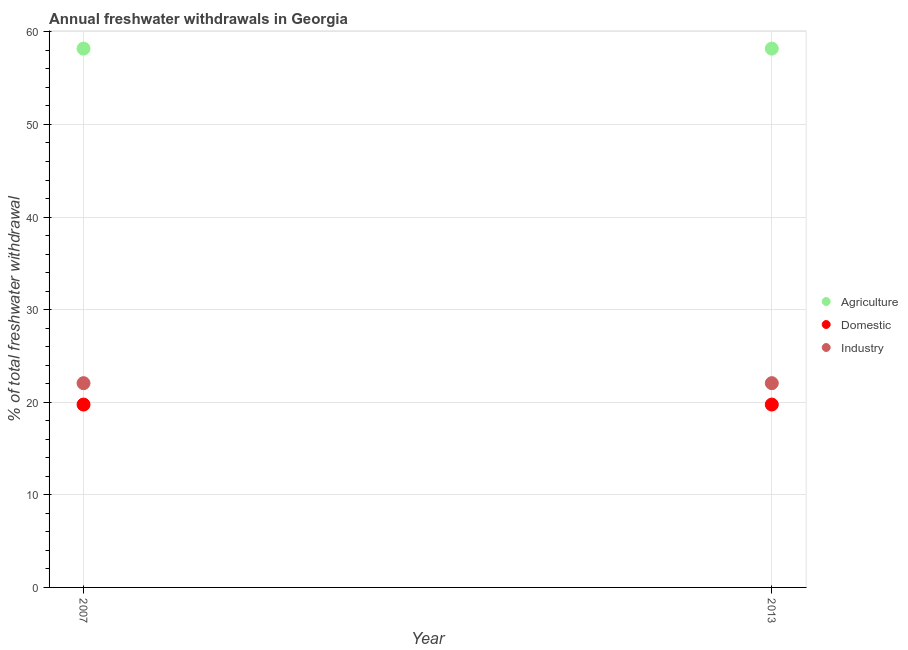How many different coloured dotlines are there?
Your answer should be compact. 3. What is the percentage of freshwater withdrawal for agriculture in 2013?
Offer a terse response. 58.19. Across all years, what is the maximum percentage of freshwater withdrawal for domestic purposes?
Your answer should be compact. 19.75. Across all years, what is the minimum percentage of freshwater withdrawal for agriculture?
Give a very brief answer. 58.19. What is the total percentage of freshwater withdrawal for domestic purposes in the graph?
Offer a terse response. 39.5. What is the difference between the percentage of freshwater withdrawal for industry in 2007 and the percentage of freshwater withdrawal for agriculture in 2013?
Offer a terse response. -36.13. What is the average percentage of freshwater withdrawal for agriculture per year?
Your response must be concise. 58.19. In the year 2007, what is the difference between the percentage of freshwater withdrawal for domestic purposes and percentage of freshwater withdrawal for agriculture?
Keep it short and to the point. -38.44. In how many years, is the percentage of freshwater withdrawal for agriculture greater than 18 %?
Keep it short and to the point. 2. What is the ratio of the percentage of freshwater withdrawal for domestic purposes in 2007 to that in 2013?
Your answer should be compact. 1. Is the percentage of freshwater withdrawal for agriculture in 2007 less than that in 2013?
Your answer should be very brief. No. In how many years, is the percentage of freshwater withdrawal for domestic purposes greater than the average percentage of freshwater withdrawal for domestic purposes taken over all years?
Keep it short and to the point. 0. Is the percentage of freshwater withdrawal for domestic purposes strictly greater than the percentage of freshwater withdrawal for agriculture over the years?
Provide a short and direct response. No. How many years are there in the graph?
Keep it short and to the point. 2. Does the graph contain any zero values?
Provide a succinct answer. No. How many legend labels are there?
Your answer should be very brief. 3. How are the legend labels stacked?
Offer a very short reply. Vertical. What is the title of the graph?
Provide a succinct answer. Annual freshwater withdrawals in Georgia. What is the label or title of the X-axis?
Your response must be concise. Year. What is the label or title of the Y-axis?
Your response must be concise. % of total freshwater withdrawal. What is the % of total freshwater withdrawal in Agriculture in 2007?
Your response must be concise. 58.19. What is the % of total freshwater withdrawal of Domestic in 2007?
Offer a terse response. 19.75. What is the % of total freshwater withdrawal in Industry in 2007?
Offer a terse response. 22.06. What is the % of total freshwater withdrawal in Agriculture in 2013?
Provide a short and direct response. 58.19. What is the % of total freshwater withdrawal in Domestic in 2013?
Keep it short and to the point. 19.75. What is the % of total freshwater withdrawal of Industry in 2013?
Your answer should be compact. 22.06. Across all years, what is the maximum % of total freshwater withdrawal of Agriculture?
Your answer should be compact. 58.19. Across all years, what is the maximum % of total freshwater withdrawal in Domestic?
Give a very brief answer. 19.75. Across all years, what is the maximum % of total freshwater withdrawal of Industry?
Make the answer very short. 22.06. Across all years, what is the minimum % of total freshwater withdrawal in Agriculture?
Your answer should be compact. 58.19. Across all years, what is the minimum % of total freshwater withdrawal of Domestic?
Your answer should be very brief. 19.75. Across all years, what is the minimum % of total freshwater withdrawal in Industry?
Make the answer very short. 22.06. What is the total % of total freshwater withdrawal of Agriculture in the graph?
Make the answer very short. 116.38. What is the total % of total freshwater withdrawal of Domestic in the graph?
Your answer should be very brief. 39.5. What is the total % of total freshwater withdrawal in Industry in the graph?
Your response must be concise. 44.12. What is the difference between the % of total freshwater withdrawal in Agriculture in 2007 and that in 2013?
Make the answer very short. 0. What is the difference between the % of total freshwater withdrawal of Industry in 2007 and that in 2013?
Offer a very short reply. 0. What is the difference between the % of total freshwater withdrawal of Agriculture in 2007 and the % of total freshwater withdrawal of Domestic in 2013?
Offer a terse response. 38.44. What is the difference between the % of total freshwater withdrawal of Agriculture in 2007 and the % of total freshwater withdrawal of Industry in 2013?
Keep it short and to the point. 36.13. What is the difference between the % of total freshwater withdrawal of Domestic in 2007 and the % of total freshwater withdrawal of Industry in 2013?
Offer a terse response. -2.31. What is the average % of total freshwater withdrawal in Agriculture per year?
Offer a very short reply. 58.19. What is the average % of total freshwater withdrawal in Domestic per year?
Ensure brevity in your answer.  19.75. What is the average % of total freshwater withdrawal in Industry per year?
Provide a succinct answer. 22.06. In the year 2007, what is the difference between the % of total freshwater withdrawal in Agriculture and % of total freshwater withdrawal in Domestic?
Ensure brevity in your answer.  38.44. In the year 2007, what is the difference between the % of total freshwater withdrawal in Agriculture and % of total freshwater withdrawal in Industry?
Provide a short and direct response. 36.13. In the year 2007, what is the difference between the % of total freshwater withdrawal in Domestic and % of total freshwater withdrawal in Industry?
Provide a succinct answer. -2.31. In the year 2013, what is the difference between the % of total freshwater withdrawal in Agriculture and % of total freshwater withdrawal in Domestic?
Keep it short and to the point. 38.44. In the year 2013, what is the difference between the % of total freshwater withdrawal in Agriculture and % of total freshwater withdrawal in Industry?
Make the answer very short. 36.13. In the year 2013, what is the difference between the % of total freshwater withdrawal of Domestic and % of total freshwater withdrawal of Industry?
Your response must be concise. -2.31. What is the ratio of the % of total freshwater withdrawal in Agriculture in 2007 to that in 2013?
Offer a very short reply. 1. What is the difference between the highest and the second highest % of total freshwater withdrawal in Agriculture?
Make the answer very short. 0. What is the difference between the highest and the second highest % of total freshwater withdrawal in Industry?
Keep it short and to the point. 0. 